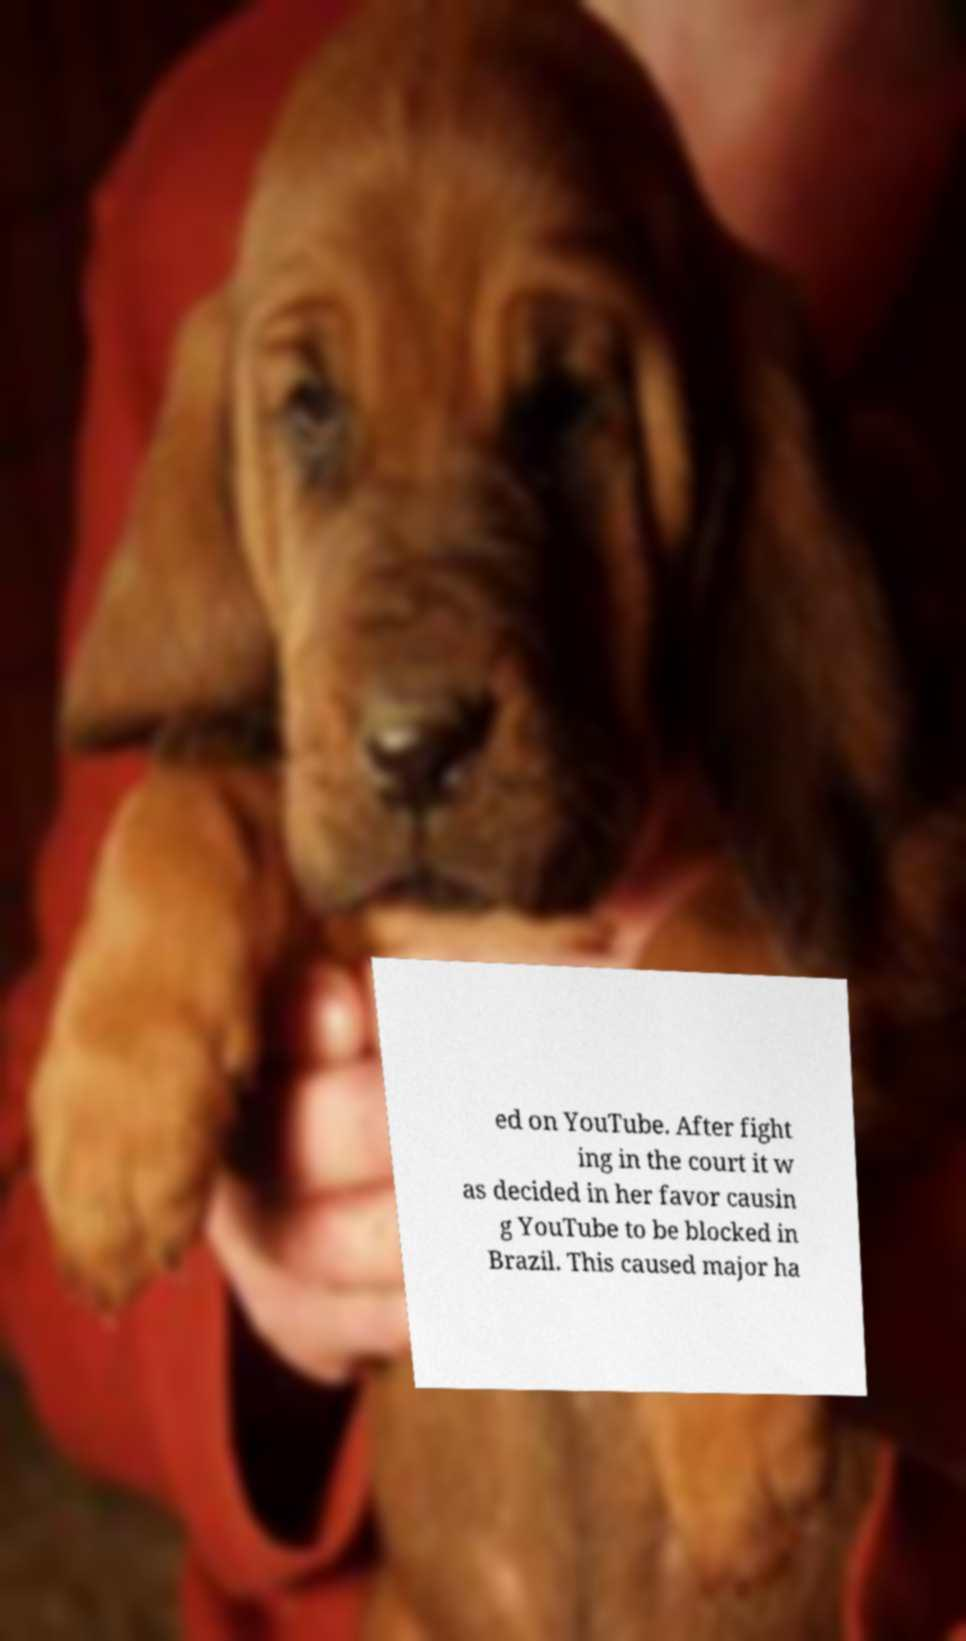Could you extract and type out the text from this image? ed on YouTube. After fight ing in the court it w as decided in her favor causin g YouTube to be blocked in Brazil. This caused major ha 